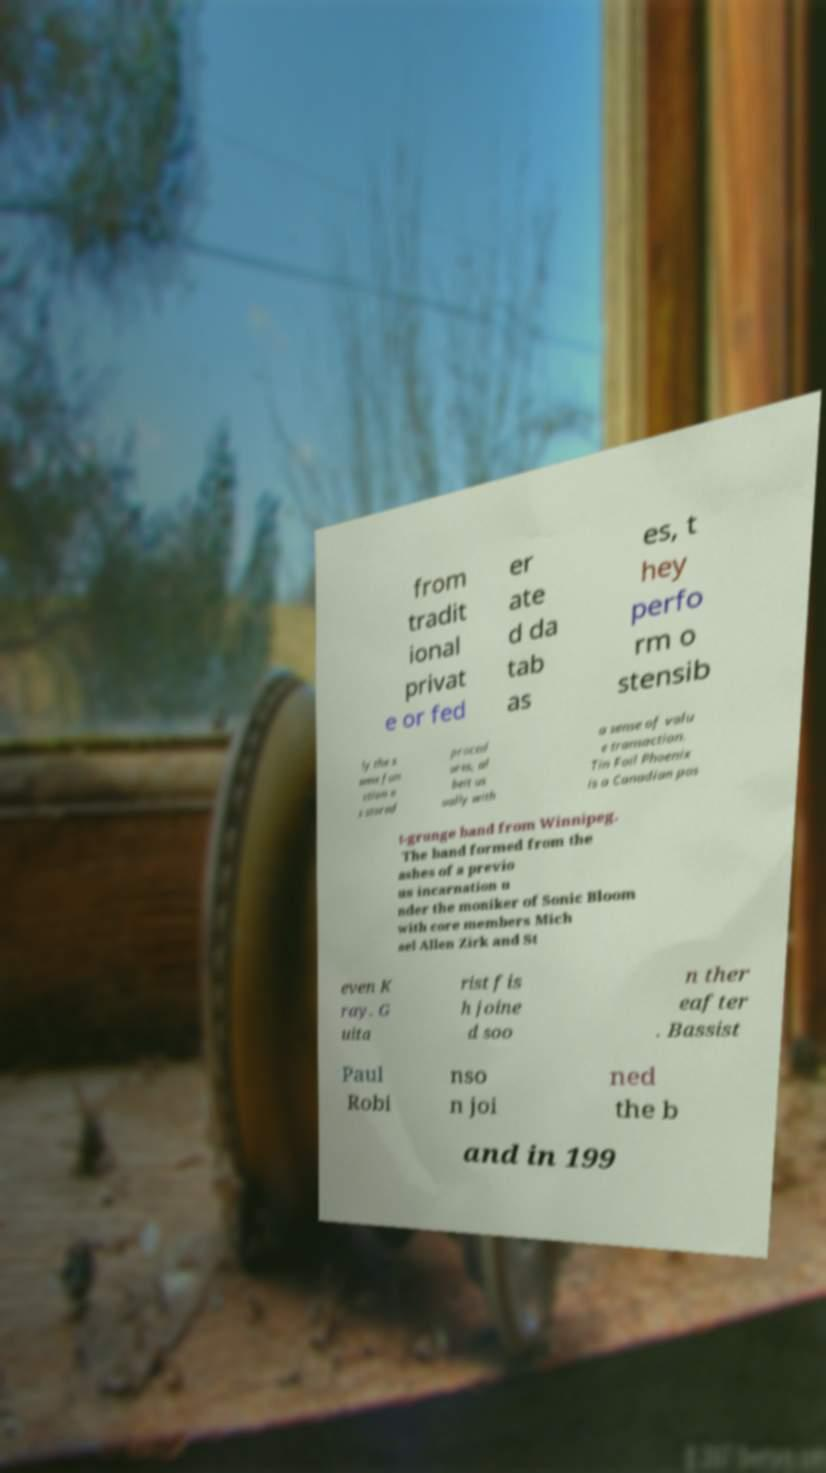There's text embedded in this image that I need extracted. Can you transcribe it verbatim? from tradit ional privat e or fed er ate d da tab as es, t hey perfo rm o stensib ly the s ame fun ction a s stored proced ures, al beit us ually with a sense of valu e transaction. Tin Foil Phoenix is a Canadian pos t-grunge band from Winnipeg. The band formed from the ashes of a previo us incarnation u nder the moniker of Sonic Bloom with core members Mich ael Allen Zirk and St even K ray. G uita rist fis h joine d soo n ther eafter . Bassist Paul Robi nso n joi ned the b and in 199 